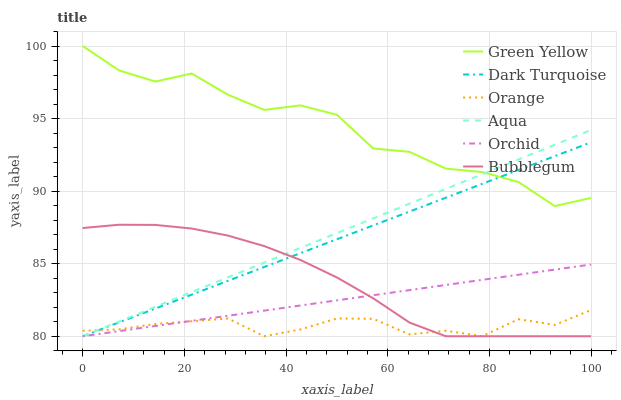Does Orange have the minimum area under the curve?
Answer yes or no. Yes. Does Green Yellow have the maximum area under the curve?
Answer yes or no. Yes. Does Aqua have the minimum area under the curve?
Answer yes or no. No. Does Aqua have the maximum area under the curve?
Answer yes or no. No. Is Orchid the smoothest?
Answer yes or no. Yes. Is Green Yellow the roughest?
Answer yes or no. Yes. Is Aqua the smoothest?
Answer yes or no. No. Is Aqua the roughest?
Answer yes or no. No. Does Dark Turquoise have the lowest value?
Answer yes or no. Yes. Does Green Yellow have the lowest value?
Answer yes or no. No. Does Green Yellow have the highest value?
Answer yes or no. Yes. Does Aqua have the highest value?
Answer yes or no. No. Is Orchid less than Green Yellow?
Answer yes or no. Yes. Is Green Yellow greater than Orange?
Answer yes or no. Yes. Does Aqua intersect Bubblegum?
Answer yes or no. Yes. Is Aqua less than Bubblegum?
Answer yes or no. No. Is Aqua greater than Bubblegum?
Answer yes or no. No. Does Orchid intersect Green Yellow?
Answer yes or no. No. 